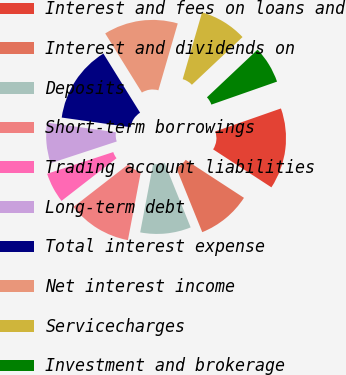<chart> <loc_0><loc_0><loc_500><loc_500><pie_chart><fcel>Interest and fees on loans and<fcel>Interest and dividends on<fcel>Deposits<fcel>Short-term borrowings<fcel>Trading account liabilities<fcel>Long-term debt<fcel>Total interest expense<fcel>Net interest income<fcel>Servicecharges<fcel>Investment and brokerage<nl><fcel>14.55%<fcel>9.7%<fcel>9.09%<fcel>11.52%<fcel>5.45%<fcel>7.27%<fcel>13.94%<fcel>13.33%<fcel>8.48%<fcel>6.67%<nl></chart> 